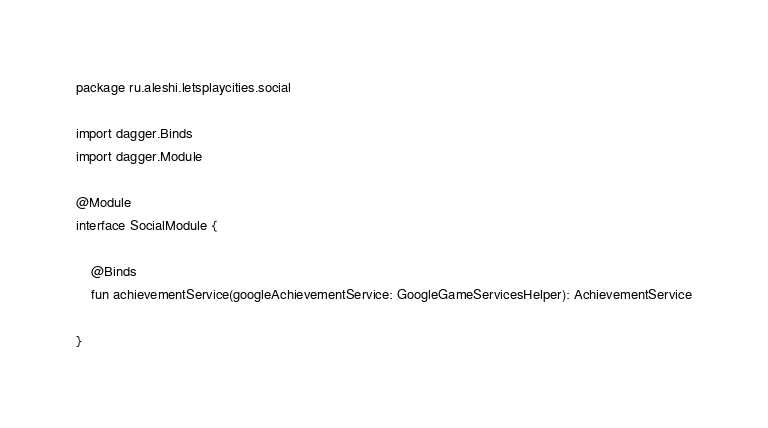<code> <loc_0><loc_0><loc_500><loc_500><_Kotlin_>package ru.aleshi.letsplaycities.social

import dagger.Binds
import dagger.Module

@Module
interface SocialModule {

    @Binds
    fun achievementService(googleAchievementService: GoogleGameServicesHelper): AchievementService

}</code> 